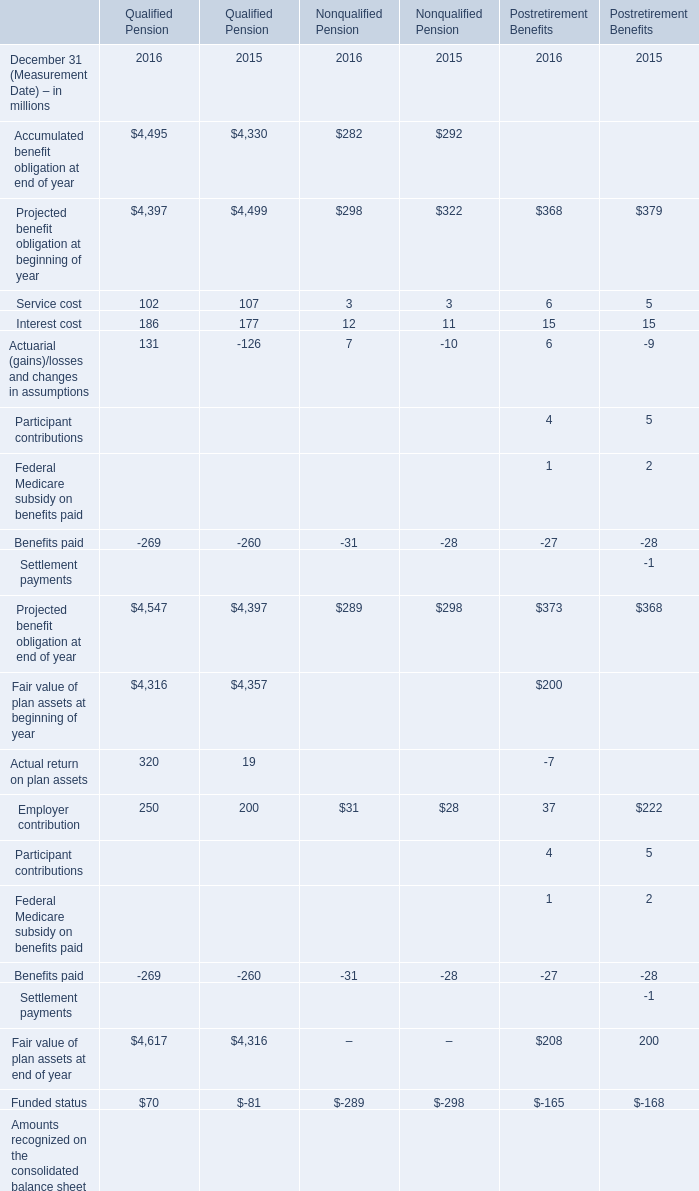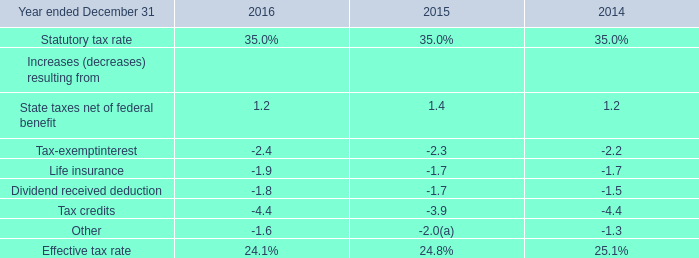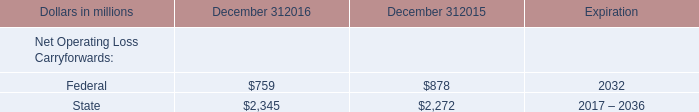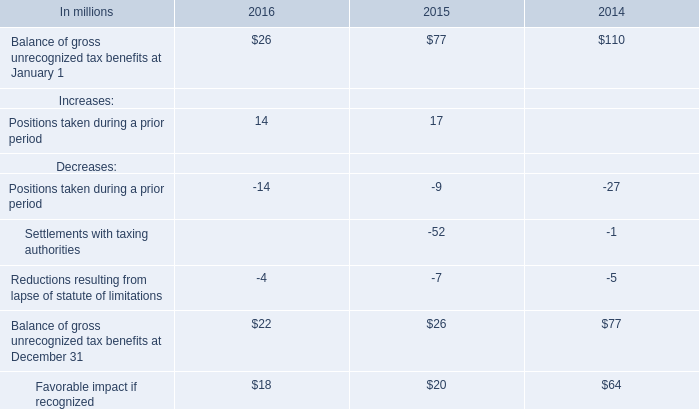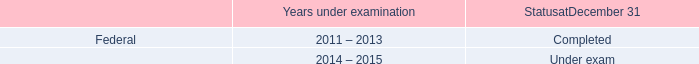What was the Projected benefit obligation at end of year for Nonqualified Pension on December 31 in 2016 ? (in million) 
Answer: 289. 